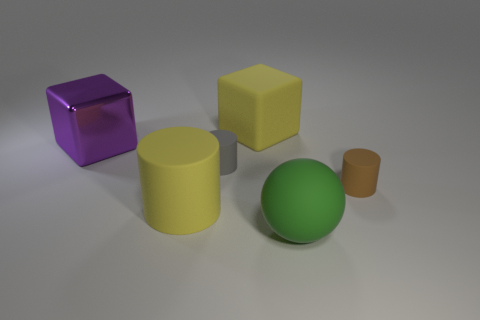What is the shape of the brown thing that is the same material as the yellow block?
Provide a short and direct response. Cylinder. Are there more yellow blocks on the left side of the large yellow cube than small gray rubber things that are right of the large green matte sphere?
Offer a terse response. No. What is the color of the big matte thing that is behind the tiny matte thing in front of the small gray matte cylinder?
Your answer should be very brief. Yellow. Are the big sphere and the large yellow cube made of the same material?
Give a very brief answer. Yes. Are there any tiny yellow shiny objects of the same shape as the big purple object?
Provide a succinct answer. No. Does the rubber object right of the green rubber thing have the same color as the matte cube?
Provide a succinct answer. No. Does the matte thing that is in front of the large yellow rubber cylinder have the same size as the block that is right of the large yellow matte cylinder?
Make the answer very short. Yes. What is the size of the yellow block that is made of the same material as the brown object?
Your answer should be very brief. Large. What number of objects are both behind the big purple object and right of the big sphere?
Provide a succinct answer. 0. What number of objects are either big blue shiny blocks or big yellow rubber objects that are in front of the shiny object?
Offer a terse response. 1. 